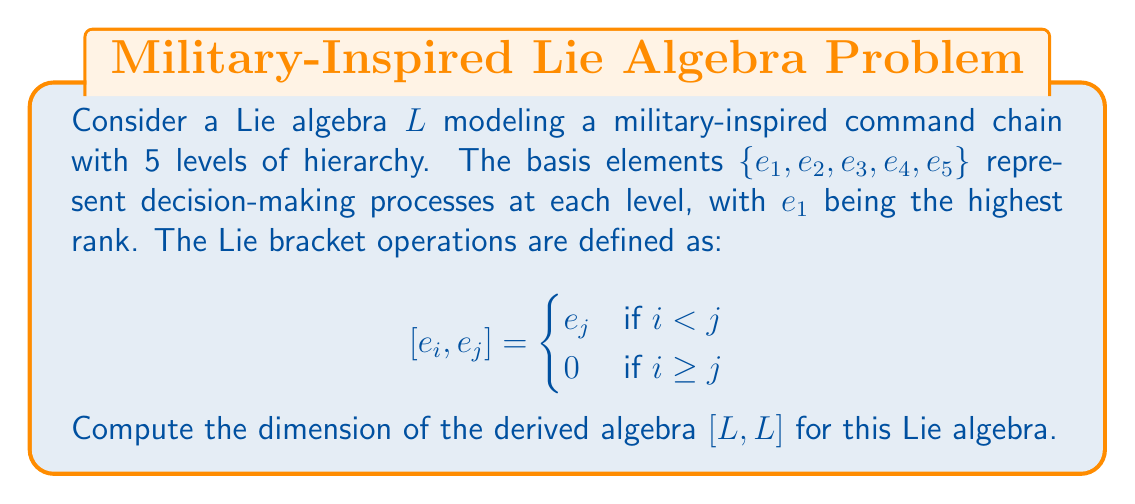Can you answer this question? To solve this problem, we'll follow these steps:

1) Recall that the derived algebra $[L,L]$ is the subspace of $L$ generated by all Lie brackets $[x,y]$ where $x,y \in L$.

2) In this case, we need to consider all possible Lie brackets between basis elements:

   $$[e_1, e_2] = e_2, [e_1, e_3] = e_3, [e_1, e_4] = e_4, [e_1, e_5] = e_5$$
   $$[e_2, e_3] = e_3, [e_2, e_4] = e_4, [e_2, e_5] = e_5$$
   $$[e_3, e_4] = e_4, [e_3, e_5] = e_5$$
   $$[e_4, e_5] = e_5$$

   All other brackets are zero.

3) We can see that $[L,L]$ is spanned by $\{e_2, e_3, e_4, e_5\}$.

4) These spanning elements are linearly independent as they are part of the original basis of $L$.

5) Therefore, the dimension of $[L,L]$ is equal to the number of these linearly independent elements.
Answer: The dimension of the derived algebra $[L,L]$ is 4. 